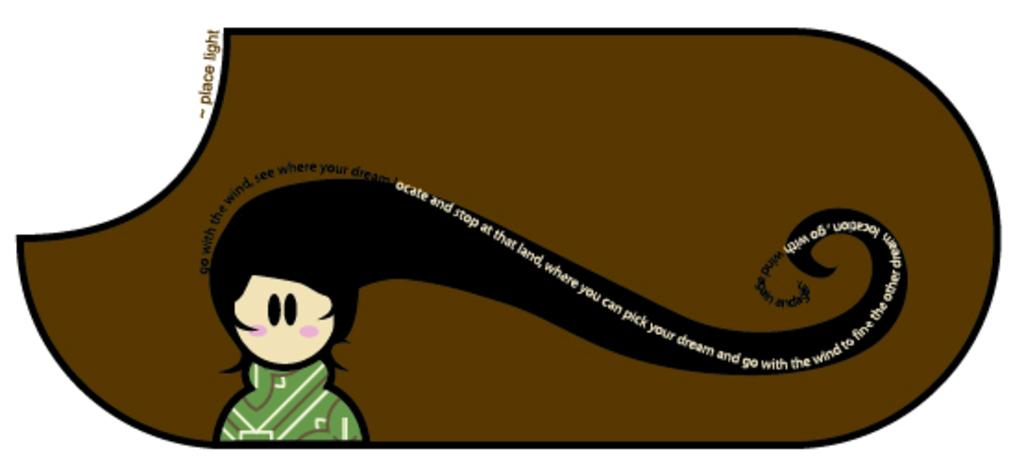What is the main subject of the image? There is a painting in the image. What is the painting depicting? The painting depicts a girl. What is the girl wearing in the painting? The girl is wearing a green dress. Are there any words or letters in the image? Yes, there is text written in the image. How many pies are on the girl's fingers in the image? There are no pies or fingers visible in the image; it features a painting of a girl wearing a green dress. 